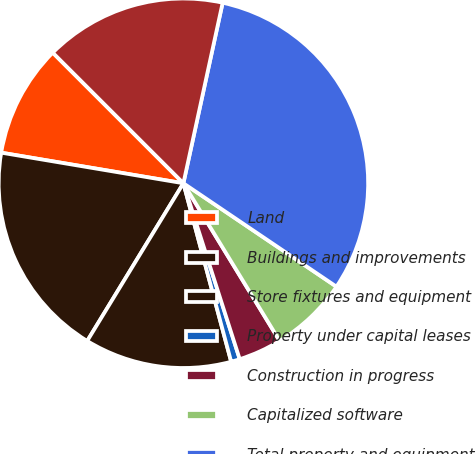<chart> <loc_0><loc_0><loc_500><loc_500><pie_chart><fcel>Land<fcel>Buildings and improvements<fcel>Store fixtures and equipment<fcel>Property under capital leases<fcel>Construction in progress<fcel>Capitalized software<fcel>Total property and equipment<fcel>Less accumulated depreciation<nl><fcel>9.85%<fcel>18.93%<fcel>12.88%<fcel>0.77%<fcel>3.79%<fcel>6.82%<fcel>31.05%<fcel>15.91%<nl></chart> 